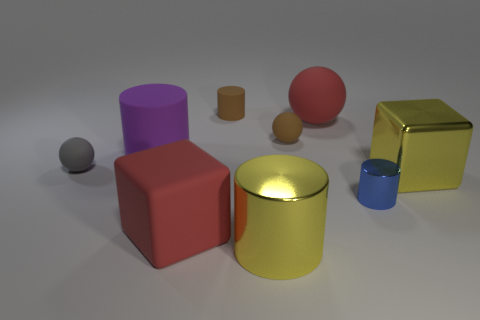Subtract all small blue metallic cylinders. How many cylinders are left? 3 Add 1 tiny red rubber cylinders. How many objects exist? 10 Subtract 1 spheres. How many spheres are left? 2 Subtract all red blocks. How many blocks are left? 1 Subtract all balls. How many objects are left? 6 Subtract all blue metal cylinders. Subtract all big purple things. How many objects are left? 7 Add 3 matte cylinders. How many matte cylinders are left? 5 Add 1 big gray balls. How many big gray balls exist? 1 Subtract 0 purple balls. How many objects are left? 9 Subtract all green cubes. Subtract all yellow spheres. How many cubes are left? 2 